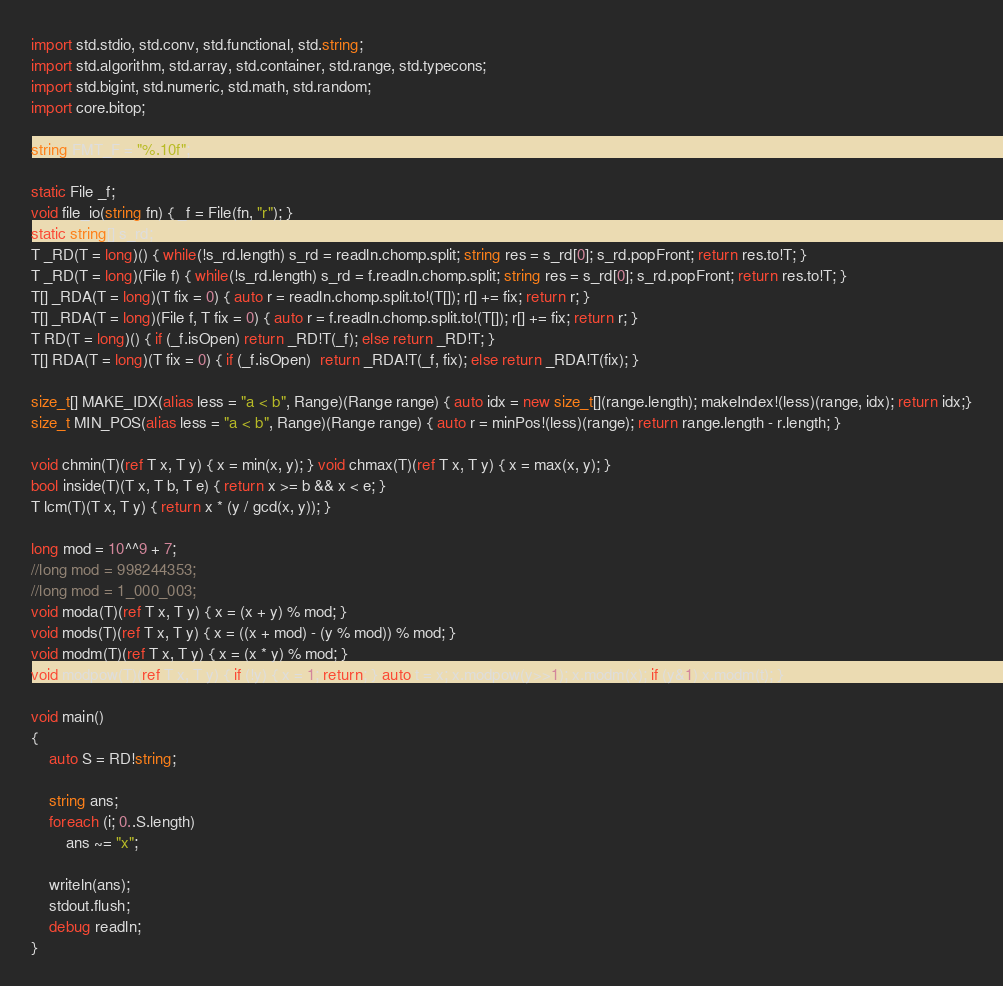Convert code to text. <code><loc_0><loc_0><loc_500><loc_500><_D_>import std.stdio, std.conv, std.functional, std.string;
import std.algorithm, std.array, std.container, std.range, std.typecons;
import std.bigint, std.numeric, std.math, std.random;
import core.bitop;

string FMT_F = "%.10f";

static File _f;
void file_io(string fn) { _f = File(fn, "r"); }
static string[] s_rd;
T _RD(T = long)() { while(!s_rd.length) s_rd = readln.chomp.split; string res = s_rd[0]; s_rd.popFront; return res.to!T; }
T _RD(T = long)(File f) { while(!s_rd.length) s_rd = f.readln.chomp.split; string res = s_rd[0]; s_rd.popFront; return res.to!T; }
T[] _RDA(T = long)(T fix = 0) { auto r = readln.chomp.split.to!(T[]); r[] += fix; return r; }
T[] _RDA(T = long)(File f, T fix = 0) { auto r = f.readln.chomp.split.to!(T[]); r[] += fix; return r; }
T RD(T = long)() { if (_f.isOpen) return _RD!T(_f); else return _RD!T; }
T[] RDA(T = long)(T fix = 0) { if (_f.isOpen)  return _RDA!T(_f, fix); else return _RDA!T(fix); }

size_t[] MAKE_IDX(alias less = "a < b", Range)(Range range) { auto idx = new size_t[](range.length); makeIndex!(less)(range, idx); return idx;}
size_t MIN_POS(alias less = "a < b", Range)(Range range) { auto r = minPos!(less)(range); return range.length - r.length; }

void chmin(T)(ref T x, T y) { x = min(x, y); } void chmax(T)(ref T x, T y) { x = max(x, y); }
bool inside(T)(T x, T b, T e) { return x >= b && x < e; }
T lcm(T)(T x, T y) { return x * (y / gcd(x, y)); }

long mod = 10^^9 + 7;
//long mod = 998244353;
//long mod = 1_000_003;
void moda(T)(ref T x, T y) { x = (x + y) % mod; }
void mods(T)(ref T x, T y) { x = ((x + mod) - (y % mod)) % mod; }
void modm(T)(ref T x, T y) { x = (x * y) % mod; }
void modpow(T)(ref T x, T y) { if (!y) { x = 1; return; } auto t = x; x.modpow(y>>1); x.modm(x); if (y&1) x.modm(t); }

void main()
{
	auto S = RD!string;

	string ans;
	foreach (i; 0..S.length)
		ans ~= "x";

	writeln(ans);
	stdout.flush;
	debug readln;
}</code> 